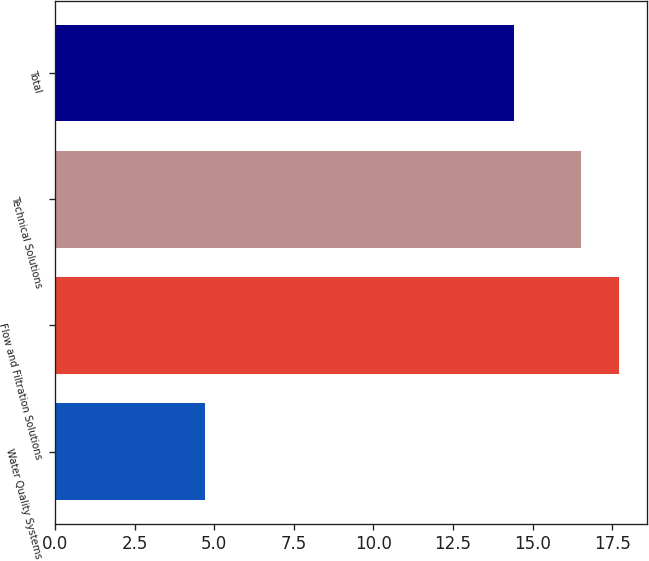Convert chart to OTSL. <chart><loc_0><loc_0><loc_500><loc_500><bar_chart><fcel>Water Quality Systems<fcel>Flow and Filtration Solutions<fcel>Technical Solutions<fcel>Total<nl><fcel>4.7<fcel>17.71<fcel>16.5<fcel>14.4<nl></chart> 